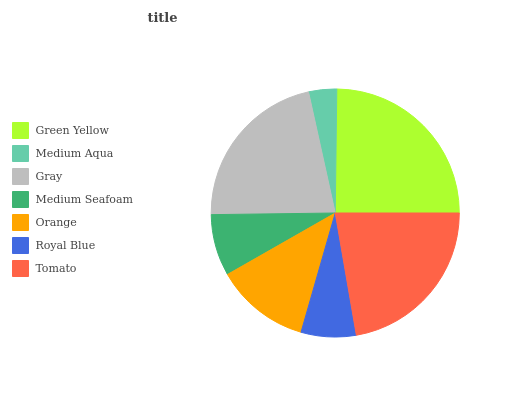Is Medium Aqua the minimum?
Answer yes or no. Yes. Is Green Yellow the maximum?
Answer yes or no. Yes. Is Gray the minimum?
Answer yes or no. No. Is Gray the maximum?
Answer yes or no. No. Is Gray greater than Medium Aqua?
Answer yes or no. Yes. Is Medium Aqua less than Gray?
Answer yes or no. Yes. Is Medium Aqua greater than Gray?
Answer yes or no. No. Is Gray less than Medium Aqua?
Answer yes or no. No. Is Orange the high median?
Answer yes or no. Yes. Is Orange the low median?
Answer yes or no. Yes. Is Green Yellow the high median?
Answer yes or no. No. Is Gray the low median?
Answer yes or no. No. 